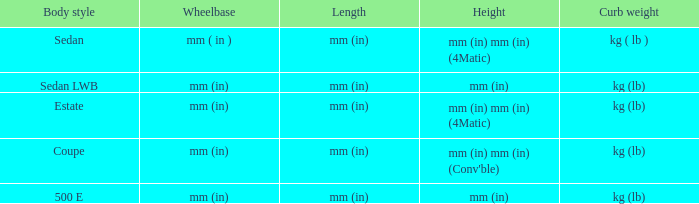What are the dimensions of the models with a height in millimeters (inches)? Mm (in), mm (in). 